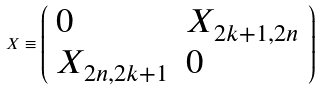Convert formula to latex. <formula><loc_0><loc_0><loc_500><loc_500>X \equiv \left ( \begin{array} { l l } { 0 } & { { X _ { 2 k + 1 , 2 n } } } \\ { { X _ { 2 n , 2 k + 1 } } } & { 0 } \end{array} \right ) \,</formula> 